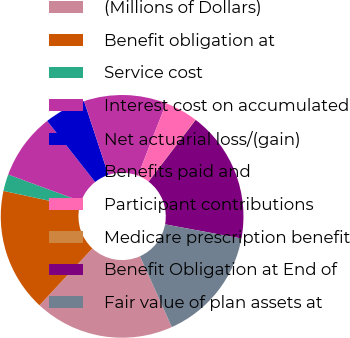<chart> <loc_0><loc_0><loc_500><loc_500><pie_chart><fcel>(Millions of Dollars)<fcel>Benefit obligation at<fcel>Service cost<fcel>Interest cost on accumulated<fcel>Net actuarial loss/(gain)<fcel>Benefits paid and<fcel>Participant contributions<fcel>Medicare prescription benefit<fcel>Benefit Obligation at End of<fcel>Fair value of plan assets at<nl><fcel>18.64%<fcel>16.45%<fcel>2.24%<fcel>8.8%<fcel>5.52%<fcel>10.98%<fcel>4.42%<fcel>0.05%<fcel>17.55%<fcel>15.36%<nl></chart> 